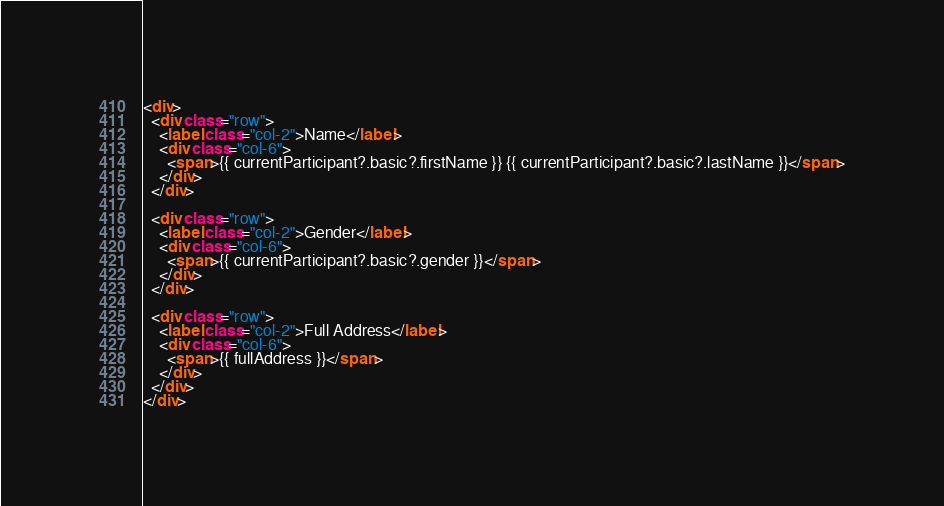Convert code to text. <code><loc_0><loc_0><loc_500><loc_500><_HTML_><div>
  <div class="row">
    <label class="col-2">Name</label>
    <div class="col-6">
      <span>{{ currentParticipant?.basic?.firstName }} {{ currentParticipant?.basic?.lastName }}</span>
    </div>
  </div>

  <div class="row">
    <label class="col-2">Gender</label>
    <div class="col-6">
      <span>{{ currentParticipant?.basic?.gender }}</span>
    </div>
  </div>

  <div class="row">
    <label class="col-2">Full Address</label>
    <div class="col-6">
      <span>{{ fullAddress }}</span>
    </div>
  </div>
</div>
</code> 